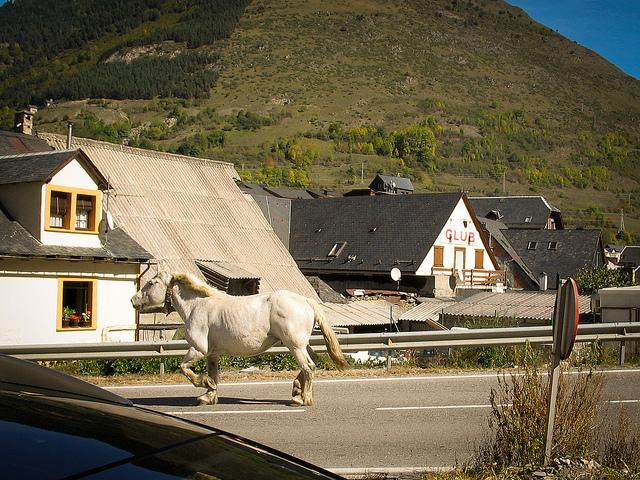Why are the roofs at street level?

Choices:
A) street missing
B) houses sank
C) broken camera
D) street below street below 